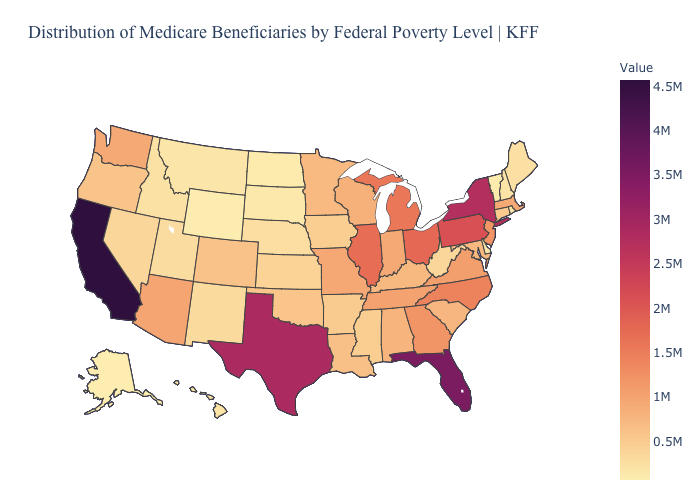Among the states that border Wisconsin , which have the highest value?
Give a very brief answer. Illinois. Is the legend a continuous bar?
Concise answer only. Yes. Among the states that border New Hampshire , which have the lowest value?
Give a very brief answer. Vermont. Among the states that border Kentucky , which have the lowest value?
Quick response, please. West Virginia. Among the states that border Tennessee , which have the lowest value?
Give a very brief answer. Mississippi. Among the states that border Wyoming , which have the highest value?
Write a very short answer. Colorado. Does the map have missing data?
Answer briefly. No. Which states hav the highest value in the MidWest?
Keep it brief. Ohio. 